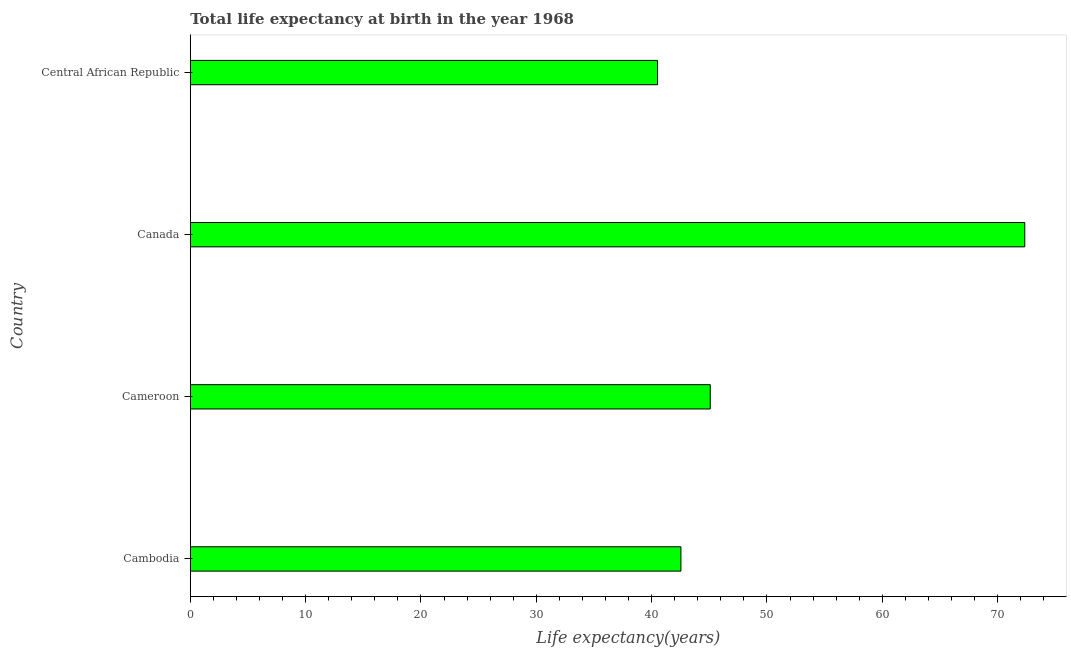Does the graph contain any zero values?
Keep it short and to the point. No. Does the graph contain grids?
Your response must be concise. No. What is the title of the graph?
Make the answer very short. Total life expectancy at birth in the year 1968. What is the label or title of the X-axis?
Your response must be concise. Life expectancy(years). What is the life expectancy at birth in Canada?
Your response must be concise. 72.35. Across all countries, what is the maximum life expectancy at birth?
Keep it short and to the point. 72.35. Across all countries, what is the minimum life expectancy at birth?
Provide a short and direct response. 40.51. In which country was the life expectancy at birth minimum?
Your response must be concise. Central African Republic. What is the sum of the life expectancy at birth?
Offer a terse response. 200.49. What is the difference between the life expectancy at birth in Cambodia and Canada?
Give a very brief answer. -29.81. What is the average life expectancy at birth per country?
Keep it short and to the point. 50.12. What is the median life expectancy at birth?
Provide a short and direct response. 43.81. In how many countries, is the life expectancy at birth greater than 4 years?
Your response must be concise. 4. What is the ratio of the life expectancy at birth in Cameroon to that in Central African Republic?
Offer a terse response. 1.11. Is the life expectancy at birth in Cameroon less than that in Central African Republic?
Provide a short and direct response. No. Is the difference between the life expectancy at birth in Cambodia and Canada greater than the difference between any two countries?
Provide a succinct answer. No. What is the difference between the highest and the second highest life expectancy at birth?
Offer a very short reply. 27.27. What is the difference between the highest and the lowest life expectancy at birth?
Your answer should be very brief. 31.84. Are all the bars in the graph horizontal?
Give a very brief answer. Yes. What is the difference between two consecutive major ticks on the X-axis?
Ensure brevity in your answer.  10. What is the Life expectancy(years) in Cambodia?
Ensure brevity in your answer.  42.54. What is the Life expectancy(years) in Cameroon?
Provide a short and direct response. 45.08. What is the Life expectancy(years) of Canada?
Your response must be concise. 72.35. What is the Life expectancy(years) in Central African Republic?
Provide a short and direct response. 40.51. What is the difference between the Life expectancy(years) in Cambodia and Cameroon?
Your response must be concise. -2.54. What is the difference between the Life expectancy(years) in Cambodia and Canada?
Provide a short and direct response. -29.81. What is the difference between the Life expectancy(years) in Cambodia and Central African Republic?
Keep it short and to the point. 2.03. What is the difference between the Life expectancy(years) in Cameroon and Canada?
Offer a terse response. -27.27. What is the difference between the Life expectancy(years) in Cameroon and Central African Republic?
Your answer should be compact. 4.57. What is the difference between the Life expectancy(years) in Canada and Central African Republic?
Offer a very short reply. 31.84. What is the ratio of the Life expectancy(years) in Cambodia to that in Cameroon?
Provide a succinct answer. 0.94. What is the ratio of the Life expectancy(years) in Cambodia to that in Canada?
Provide a short and direct response. 0.59. What is the ratio of the Life expectancy(years) in Cameroon to that in Canada?
Give a very brief answer. 0.62. What is the ratio of the Life expectancy(years) in Cameroon to that in Central African Republic?
Keep it short and to the point. 1.11. What is the ratio of the Life expectancy(years) in Canada to that in Central African Republic?
Keep it short and to the point. 1.79. 